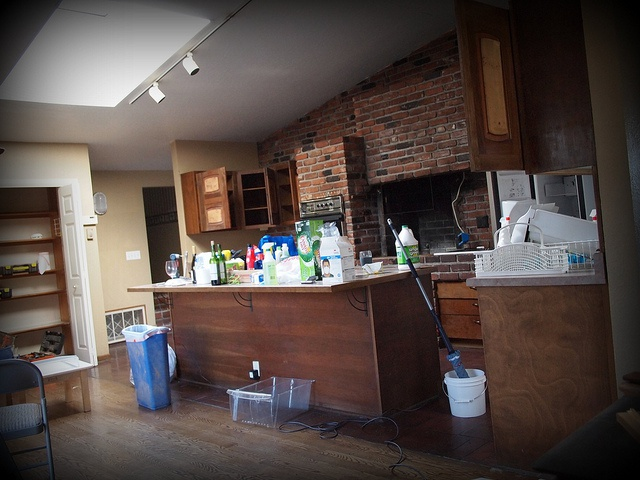Describe the objects in this image and their specific colors. I can see refrigerator in black and gray tones, chair in black, gray, and maroon tones, oven in black, gray, and darkgray tones, bottle in black, lightgray, darkgray, lightblue, and gray tones, and bottle in black, white, darkgray, and gray tones in this image. 